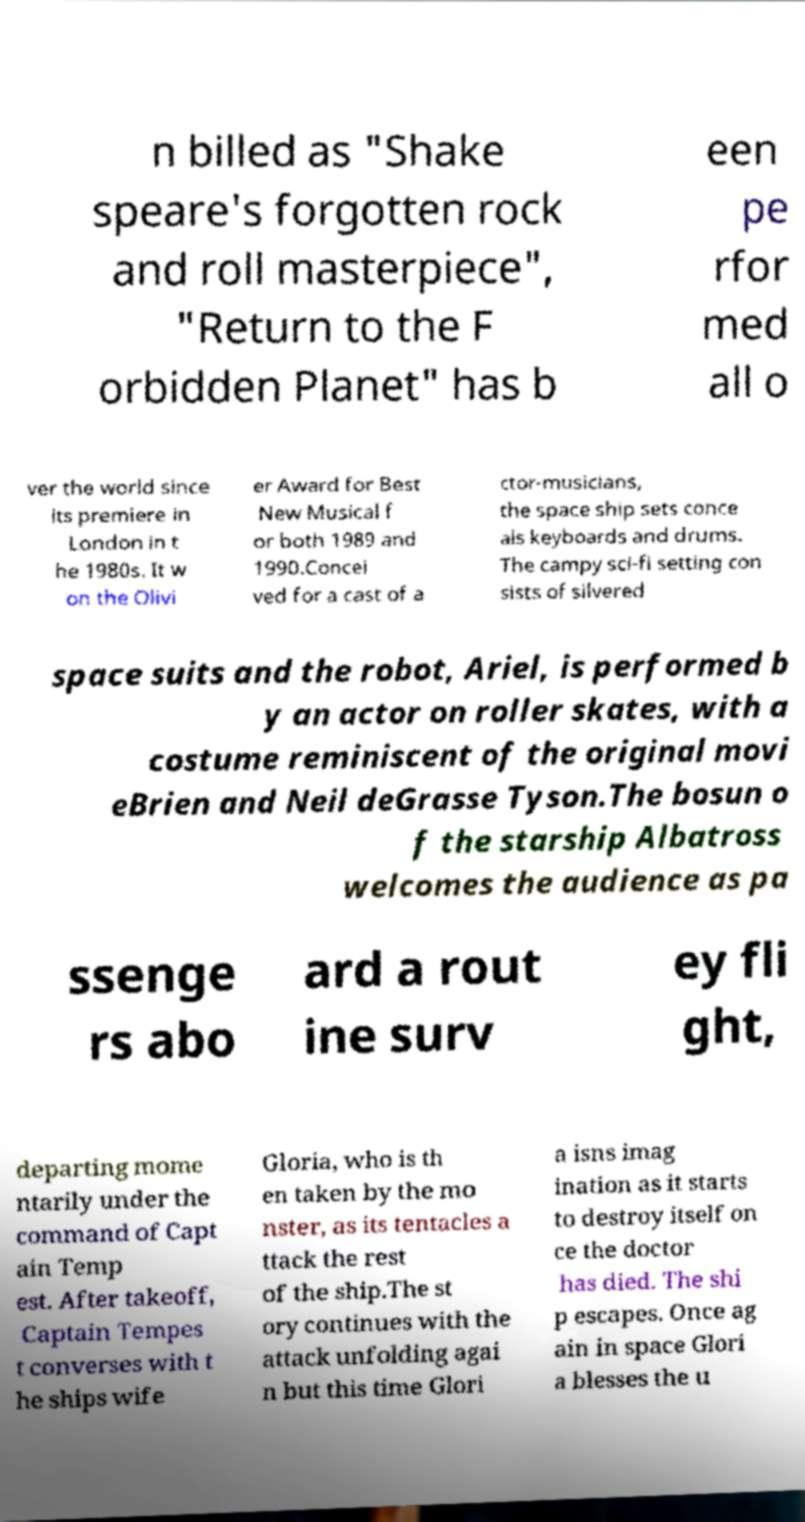There's text embedded in this image that I need extracted. Can you transcribe it verbatim? n billed as "Shake speare's forgotten rock and roll masterpiece", "Return to the F orbidden Planet" has b een pe rfor med all o ver the world since its premiere in London in t he 1980s. It w on the Olivi er Award for Best New Musical f or both 1989 and 1990.Concei ved for a cast of a ctor-musicians, the space ship sets conce als keyboards and drums. The campy sci-fi setting con sists of silvered space suits and the robot, Ariel, is performed b y an actor on roller skates, with a costume reminiscent of the original movi eBrien and Neil deGrasse Tyson.The bosun o f the starship Albatross welcomes the audience as pa ssenge rs abo ard a rout ine surv ey fli ght, departing mome ntarily under the command of Capt ain Temp est. After takeoff, Captain Tempes t converses with t he ships wife Gloria, who is th en taken by the mo nster, as its tentacles a ttack the rest of the ship.The st ory continues with the attack unfolding agai n but this time Glori a isns imag ination as it starts to destroy itself on ce the doctor has died. The shi p escapes. Once ag ain in space Glori a blesses the u 